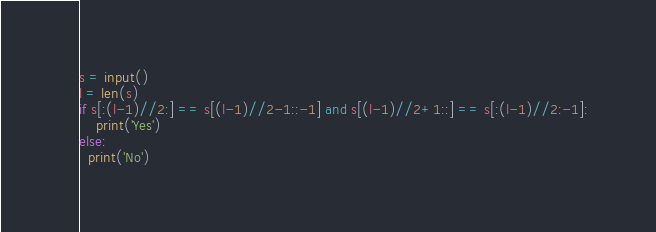<code> <loc_0><loc_0><loc_500><loc_500><_Python_>s = input()
l = len(s)
if s[:(l-1)//2:] == s[(l-1)//2-1::-1] and s[(l-1)//2+1::] == s[:(l-1)//2:-1]:
    print('Yes')
else:
  print('No')</code> 